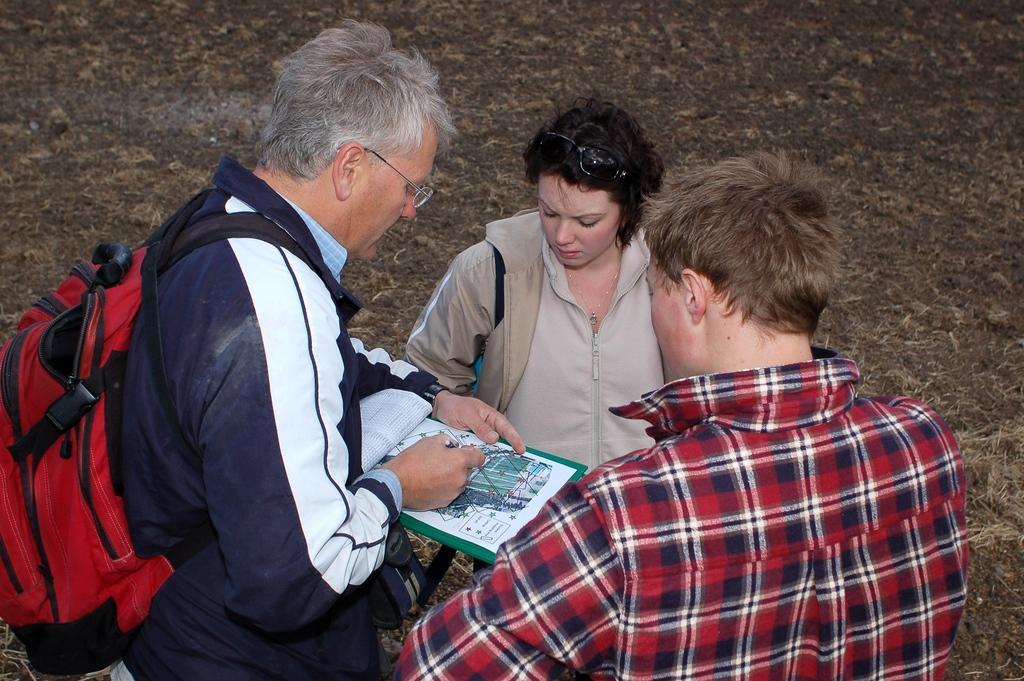In one or two sentences, can you explain what this image depicts? In this image we can see few people. A person is wearing a backpack and holding some objects in his hand. 